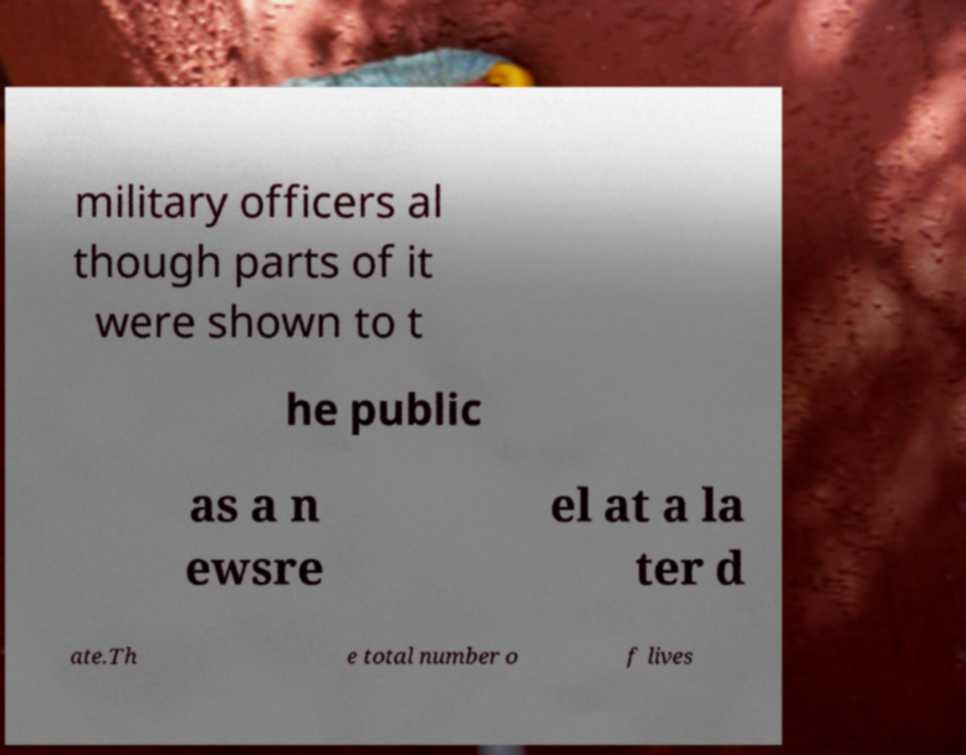Could you extract and type out the text from this image? military officers al though parts of it were shown to t he public as a n ewsre el at a la ter d ate.Th e total number o f lives 